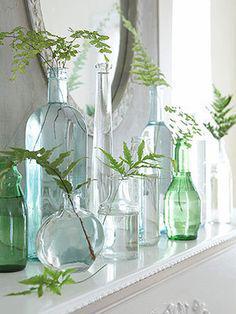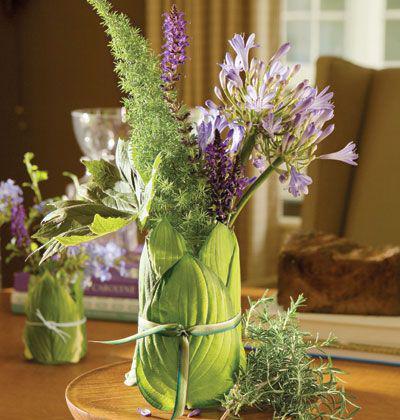The first image is the image on the left, the second image is the image on the right. Given the left and right images, does the statement "There are plants in drinking glasses, one of which is short." hold true? Answer yes or no. No. 